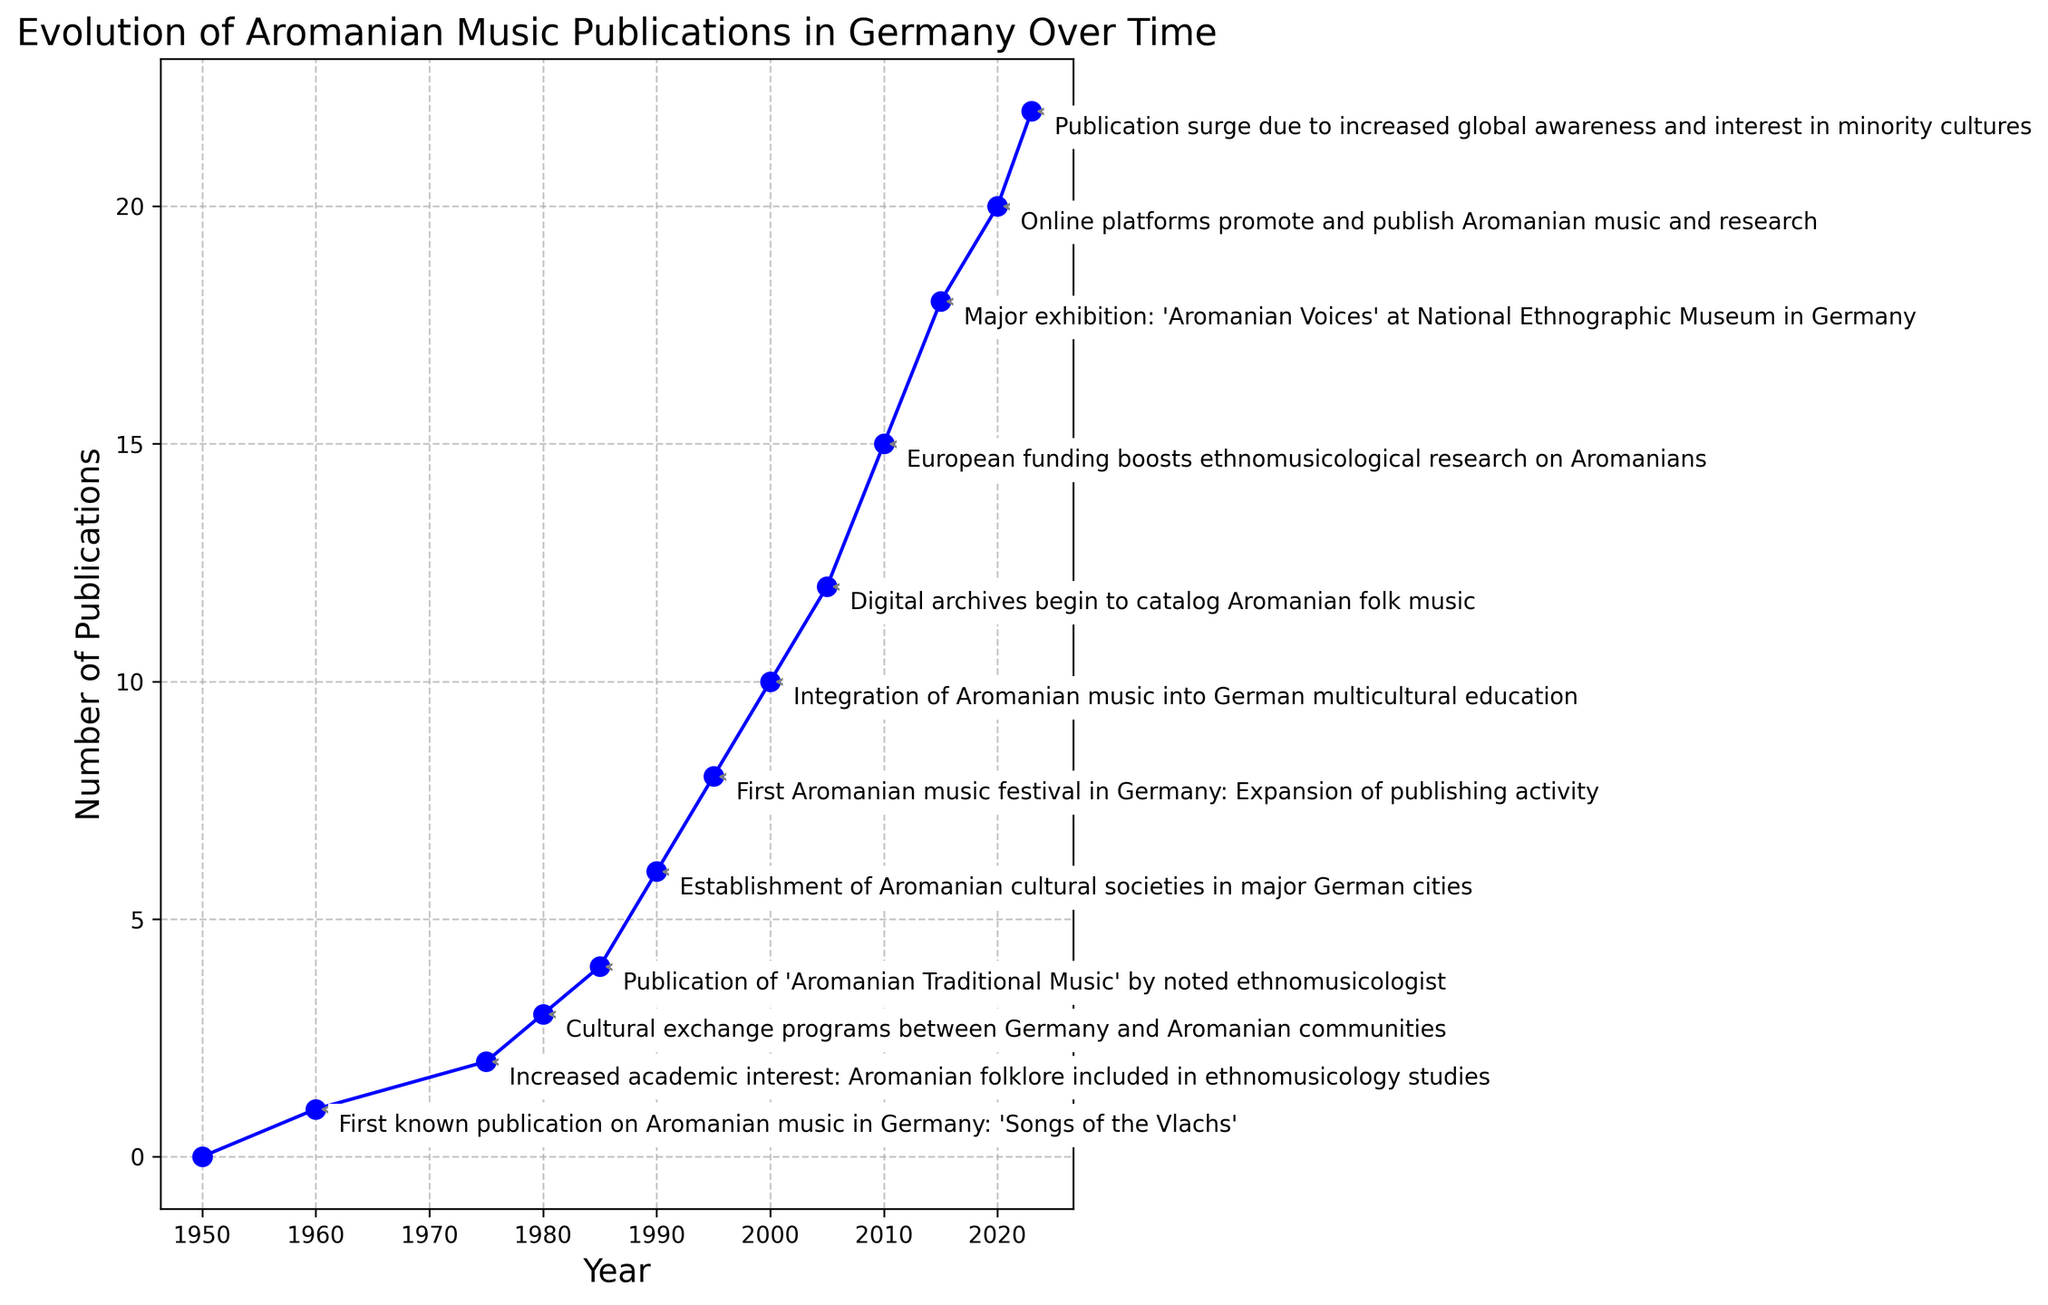What year saw the first known publication on Aromanian music in Germany? The figure annotates significant milestones, with the first known publication marked in 1960.
Answer: 1960 How many Aromanian music publications were there in 1995? By referring to the figure, you can directly see the number of publications for each year. For 1995, the plot shows 8 publications.
Answer: 8 Which year had the highest increase in the number of publications compared to the previous milestone? The largest increases can be evaluated by checking the difference in publications between sequential annotated milestones. From 1990 to 1995, the number grew by 8 - 6 = 2. From 2000 to 2005, it grew by 12 - 10 = 2. From 2010 to 2015, it grew by 18 - 15 = 3. From 2015 to 2020, it grew by 20 - 18 = 2. 2010 to 2015 had the largest increase (3).
Answer: 2010 to 2015 What can be inferred about the trend in Aromanian music publications in Germany after the establishment of Aromanian cultural societies? According to the figure, there is a noticeable increase in the number of publications after 1990, followed by strong growth in subsequent years. This suggests the establishment of societies likely boosted publication activity.
Answer: Increase in growth trend Describe what major event occurred in 2015 according to the figure. The annotation for 2015 reads: "Major exhibition: 'Aromanian Voices' at National Ethnographic Museum in Germany."
Answer: Major exhibition: 'Aromanian Voices' In which decade did the number of Aromanian music publications in Germany breach the double digits? To determine this, locate when the number of publications first reaches or exceeds 10. According to the plot, this happened in the year 2000, within the 1990s decade.
Answer: 1990s Comparing 1985 and 1990, which year had more publications, and by how many? According to the figure, 1985 had 4 publications and 1990 had 6 publications. The difference is 6 - 4 = 2.
Answer: 1990 by 2 publications What visual change happens to the annotations as the number of publications increases? Observing the plot, the complexity and frequency of the annotations seem to increase as the number of publications goes up, suggesting more significant events and milestones are marked.
Answer: More detailed/more frequent annotations What milestone is annotated in 2005, and why is it significant? The annotation for 2005 notes the beginning of digital archives to catalog Aromanian folk music. This is significant as it marks the transition to digital documentation, which likely contributed to increased access and dissemination.
Answer: Digital archives begin How has European funding influenced the publication of Aromanian music in Germany? The plot indicates a major increase in publications around 2010, annotated with "European funding boosts ethnomusicological research on Aromanians," showing a clear positive impact.
Answer: Boost in publications around 2010 